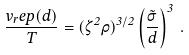<formula> <loc_0><loc_0><loc_500><loc_500>\frac { v _ { r } e p ( d ) } { T } = ( \zeta ^ { 2 } \rho ) ^ { 3 / 2 } \left ( \frac { \tilde { \sigma } } { d } \right ) ^ { 3 } \, .</formula> 